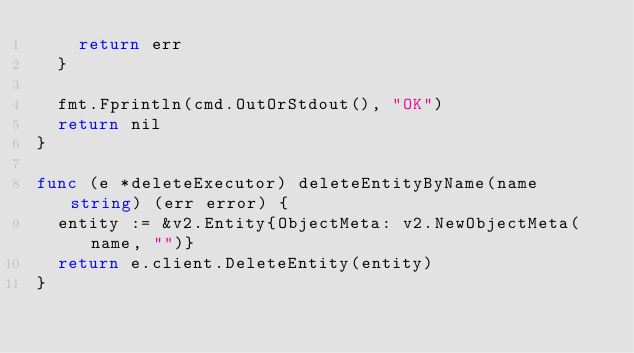<code> <loc_0><loc_0><loc_500><loc_500><_Go_>		return err
	}

	fmt.Fprintln(cmd.OutOrStdout(), "OK")
	return nil
}

func (e *deleteExecutor) deleteEntityByName(name string) (err error) {
	entity := &v2.Entity{ObjectMeta: v2.NewObjectMeta(name, "")}
	return e.client.DeleteEntity(entity)
}
</code> 